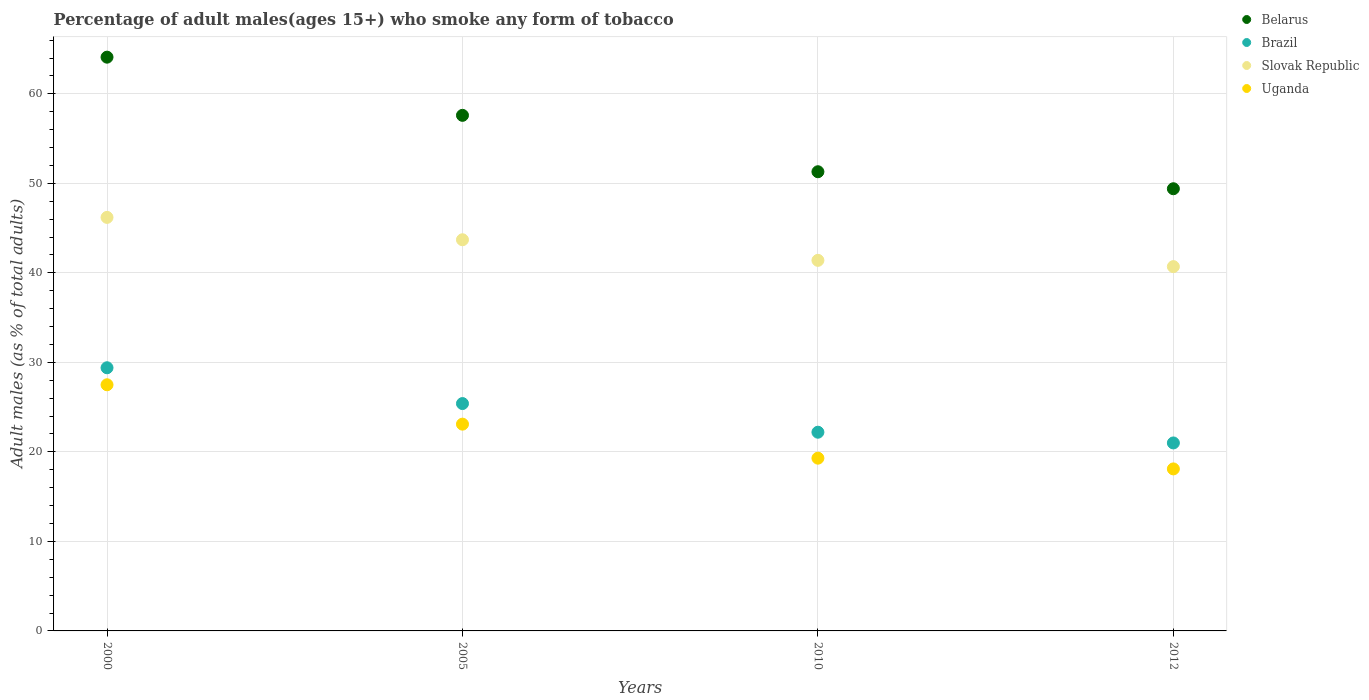How many different coloured dotlines are there?
Make the answer very short. 4. Is the number of dotlines equal to the number of legend labels?
Your answer should be compact. Yes. What is the percentage of adult males who smoke in Belarus in 2005?
Provide a short and direct response. 57.6. Across all years, what is the maximum percentage of adult males who smoke in Brazil?
Offer a very short reply. 29.4. Across all years, what is the minimum percentage of adult males who smoke in Slovak Republic?
Your response must be concise. 40.7. In which year was the percentage of adult males who smoke in Uganda maximum?
Provide a short and direct response. 2000. In which year was the percentage of adult males who smoke in Belarus minimum?
Provide a succinct answer. 2012. What is the total percentage of adult males who smoke in Belarus in the graph?
Offer a very short reply. 222.4. What is the difference between the percentage of adult males who smoke in Belarus in 2000 and that in 2005?
Provide a short and direct response. 6.5. What is the difference between the percentage of adult males who smoke in Belarus in 2005 and the percentage of adult males who smoke in Uganda in 2000?
Make the answer very short. 30.1. What is the average percentage of adult males who smoke in Belarus per year?
Your response must be concise. 55.6. In the year 2012, what is the difference between the percentage of adult males who smoke in Brazil and percentage of adult males who smoke in Slovak Republic?
Make the answer very short. -19.7. What is the ratio of the percentage of adult males who smoke in Slovak Republic in 2010 to that in 2012?
Your response must be concise. 1.02. Is the percentage of adult males who smoke in Slovak Republic in 2005 less than that in 2012?
Make the answer very short. No. What is the difference between the highest and the lowest percentage of adult males who smoke in Brazil?
Offer a very short reply. 8.4. Is the sum of the percentage of adult males who smoke in Uganda in 2005 and 2010 greater than the maximum percentage of adult males who smoke in Belarus across all years?
Your answer should be compact. No. Is the percentage of adult males who smoke in Brazil strictly greater than the percentage of adult males who smoke in Slovak Republic over the years?
Provide a short and direct response. No. How many years are there in the graph?
Make the answer very short. 4. Where does the legend appear in the graph?
Ensure brevity in your answer.  Top right. How are the legend labels stacked?
Offer a terse response. Vertical. What is the title of the graph?
Your answer should be compact. Percentage of adult males(ages 15+) who smoke any form of tobacco. What is the label or title of the Y-axis?
Your answer should be very brief. Adult males (as % of total adults). What is the Adult males (as % of total adults) in Belarus in 2000?
Make the answer very short. 64.1. What is the Adult males (as % of total adults) of Brazil in 2000?
Your response must be concise. 29.4. What is the Adult males (as % of total adults) of Slovak Republic in 2000?
Provide a short and direct response. 46.2. What is the Adult males (as % of total adults) of Uganda in 2000?
Ensure brevity in your answer.  27.5. What is the Adult males (as % of total adults) in Belarus in 2005?
Your answer should be very brief. 57.6. What is the Adult males (as % of total adults) of Brazil in 2005?
Ensure brevity in your answer.  25.4. What is the Adult males (as % of total adults) in Slovak Republic in 2005?
Your response must be concise. 43.7. What is the Adult males (as % of total adults) of Uganda in 2005?
Provide a succinct answer. 23.1. What is the Adult males (as % of total adults) of Belarus in 2010?
Your response must be concise. 51.3. What is the Adult males (as % of total adults) of Brazil in 2010?
Offer a terse response. 22.2. What is the Adult males (as % of total adults) in Slovak Republic in 2010?
Offer a terse response. 41.4. What is the Adult males (as % of total adults) of Uganda in 2010?
Provide a succinct answer. 19.3. What is the Adult males (as % of total adults) in Belarus in 2012?
Your response must be concise. 49.4. What is the Adult males (as % of total adults) in Brazil in 2012?
Offer a very short reply. 21. What is the Adult males (as % of total adults) in Slovak Republic in 2012?
Keep it short and to the point. 40.7. Across all years, what is the maximum Adult males (as % of total adults) in Belarus?
Ensure brevity in your answer.  64.1. Across all years, what is the maximum Adult males (as % of total adults) in Brazil?
Offer a terse response. 29.4. Across all years, what is the maximum Adult males (as % of total adults) of Slovak Republic?
Offer a very short reply. 46.2. Across all years, what is the minimum Adult males (as % of total adults) in Belarus?
Your response must be concise. 49.4. Across all years, what is the minimum Adult males (as % of total adults) of Brazil?
Ensure brevity in your answer.  21. Across all years, what is the minimum Adult males (as % of total adults) in Slovak Republic?
Offer a very short reply. 40.7. What is the total Adult males (as % of total adults) in Belarus in the graph?
Offer a terse response. 222.4. What is the total Adult males (as % of total adults) in Slovak Republic in the graph?
Keep it short and to the point. 172. What is the total Adult males (as % of total adults) in Uganda in the graph?
Keep it short and to the point. 88. What is the difference between the Adult males (as % of total adults) of Belarus in 2000 and that in 2010?
Your answer should be compact. 12.8. What is the difference between the Adult males (as % of total adults) of Brazil in 2000 and that in 2010?
Ensure brevity in your answer.  7.2. What is the difference between the Adult males (as % of total adults) of Belarus in 2000 and that in 2012?
Provide a succinct answer. 14.7. What is the difference between the Adult males (as % of total adults) of Brazil in 2000 and that in 2012?
Ensure brevity in your answer.  8.4. What is the difference between the Adult males (as % of total adults) in Belarus in 2005 and that in 2012?
Offer a very short reply. 8.2. What is the difference between the Adult males (as % of total adults) in Brazil in 2005 and that in 2012?
Provide a succinct answer. 4.4. What is the difference between the Adult males (as % of total adults) in Belarus in 2010 and that in 2012?
Give a very brief answer. 1.9. What is the difference between the Adult males (as % of total adults) of Slovak Republic in 2010 and that in 2012?
Keep it short and to the point. 0.7. What is the difference between the Adult males (as % of total adults) of Belarus in 2000 and the Adult males (as % of total adults) of Brazil in 2005?
Keep it short and to the point. 38.7. What is the difference between the Adult males (as % of total adults) in Belarus in 2000 and the Adult males (as % of total adults) in Slovak Republic in 2005?
Ensure brevity in your answer.  20.4. What is the difference between the Adult males (as % of total adults) in Belarus in 2000 and the Adult males (as % of total adults) in Uganda in 2005?
Ensure brevity in your answer.  41. What is the difference between the Adult males (as % of total adults) in Brazil in 2000 and the Adult males (as % of total adults) in Slovak Republic in 2005?
Ensure brevity in your answer.  -14.3. What is the difference between the Adult males (as % of total adults) in Slovak Republic in 2000 and the Adult males (as % of total adults) in Uganda in 2005?
Offer a very short reply. 23.1. What is the difference between the Adult males (as % of total adults) of Belarus in 2000 and the Adult males (as % of total adults) of Brazil in 2010?
Make the answer very short. 41.9. What is the difference between the Adult males (as % of total adults) in Belarus in 2000 and the Adult males (as % of total adults) in Slovak Republic in 2010?
Your response must be concise. 22.7. What is the difference between the Adult males (as % of total adults) in Belarus in 2000 and the Adult males (as % of total adults) in Uganda in 2010?
Your answer should be very brief. 44.8. What is the difference between the Adult males (as % of total adults) in Brazil in 2000 and the Adult males (as % of total adults) in Uganda in 2010?
Offer a terse response. 10.1. What is the difference between the Adult males (as % of total adults) of Slovak Republic in 2000 and the Adult males (as % of total adults) of Uganda in 2010?
Offer a very short reply. 26.9. What is the difference between the Adult males (as % of total adults) in Belarus in 2000 and the Adult males (as % of total adults) in Brazil in 2012?
Offer a very short reply. 43.1. What is the difference between the Adult males (as % of total adults) in Belarus in 2000 and the Adult males (as % of total adults) in Slovak Republic in 2012?
Your answer should be compact. 23.4. What is the difference between the Adult males (as % of total adults) of Belarus in 2000 and the Adult males (as % of total adults) of Uganda in 2012?
Your answer should be very brief. 46. What is the difference between the Adult males (as % of total adults) in Slovak Republic in 2000 and the Adult males (as % of total adults) in Uganda in 2012?
Give a very brief answer. 28.1. What is the difference between the Adult males (as % of total adults) in Belarus in 2005 and the Adult males (as % of total adults) in Brazil in 2010?
Make the answer very short. 35.4. What is the difference between the Adult males (as % of total adults) in Belarus in 2005 and the Adult males (as % of total adults) in Uganda in 2010?
Offer a terse response. 38.3. What is the difference between the Adult males (as % of total adults) of Slovak Republic in 2005 and the Adult males (as % of total adults) of Uganda in 2010?
Provide a succinct answer. 24.4. What is the difference between the Adult males (as % of total adults) of Belarus in 2005 and the Adult males (as % of total adults) of Brazil in 2012?
Provide a succinct answer. 36.6. What is the difference between the Adult males (as % of total adults) in Belarus in 2005 and the Adult males (as % of total adults) in Slovak Republic in 2012?
Provide a short and direct response. 16.9. What is the difference between the Adult males (as % of total adults) of Belarus in 2005 and the Adult males (as % of total adults) of Uganda in 2012?
Ensure brevity in your answer.  39.5. What is the difference between the Adult males (as % of total adults) in Brazil in 2005 and the Adult males (as % of total adults) in Slovak Republic in 2012?
Make the answer very short. -15.3. What is the difference between the Adult males (as % of total adults) of Slovak Republic in 2005 and the Adult males (as % of total adults) of Uganda in 2012?
Make the answer very short. 25.6. What is the difference between the Adult males (as % of total adults) of Belarus in 2010 and the Adult males (as % of total adults) of Brazil in 2012?
Provide a succinct answer. 30.3. What is the difference between the Adult males (as % of total adults) of Belarus in 2010 and the Adult males (as % of total adults) of Uganda in 2012?
Offer a terse response. 33.2. What is the difference between the Adult males (as % of total adults) of Brazil in 2010 and the Adult males (as % of total adults) of Slovak Republic in 2012?
Your response must be concise. -18.5. What is the difference between the Adult males (as % of total adults) of Slovak Republic in 2010 and the Adult males (as % of total adults) of Uganda in 2012?
Give a very brief answer. 23.3. What is the average Adult males (as % of total adults) in Belarus per year?
Your answer should be compact. 55.6. What is the average Adult males (as % of total adults) in Brazil per year?
Your response must be concise. 24.5. What is the average Adult males (as % of total adults) of Slovak Republic per year?
Give a very brief answer. 43. What is the average Adult males (as % of total adults) of Uganda per year?
Make the answer very short. 22. In the year 2000, what is the difference between the Adult males (as % of total adults) of Belarus and Adult males (as % of total adults) of Brazil?
Offer a terse response. 34.7. In the year 2000, what is the difference between the Adult males (as % of total adults) of Belarus and Adult males (as % of total adults) of Uganda?
Ensure brevity in your answer.  36.6. In the year 2000, what is the difference between the Adult males (as % of total adults) of Brazil and Adult males (as % of total adults) of Slovak Republic?
Your answer should be compact. -16.8. In the year 2000, what is the difference between the Adult males (as % of total adults) of Slovak Republic and Adult males (as % of total adults) of Uganda?
Your answer should be very brief. 18.7. In the year 2005, what is the difference between the Adult males (as % of total adults) in Belarus and Adult males (as % of total adults) in Brazil?
Your answer should be compact. 32.2. In the year 2005, what is the difference between the Adult males (as % of total adults) of Belarus and Adult males (as % of total adults) of Uganda?
Provide a short and direct response. 34.5. In the year 2005, what is the difference between the Adult males (as % of total adults) of Brazil and Adult males (as % of total adults) of Slovak Republic?
Ensure brevity in your answer.  -18.3. In the year 2005, what is the difference between the Adult males (as % of total adults) in Slovak Republic and Adult males (as % of total adults) in Uganda?
Offer a terse response. 20.6. In the year 2010, what is the difference between the Adult males (as % of total adults) of Belarus and Adult males (as % of total adults) of Brazil?
Keep it short and to the point. 29.1. In the year 2010, what is the difference between the Adult males (as % of total adults) of Belarus and Adult males (as % of total adults) of Uganda?
Provide a short and direct response. 32. In the year 2010, what is the difference between the Adult males (as % of total adults) in Brazil and Adult males (as % of total adults) in Slovak Republic?
Give a very brief answer. -19.2. In the year 2010, what is the difference between the Adult males (as % of total adults) of Brazil and Adult males (as % of total adults) of Uganda?
Provide a short and direct response. 2.9. In the year 2010, what is the difference between the Adult males (as % of total adults) of Slovak Republic and Adult males (as % of total adults) of Uganda?
Your answer should be very brief. 22.1. In the year 2012, what is the difference between the Adult males (as % of total adults) of Belarus and Adult males (as % of total adults) of Brazil?
Offer a very short reply. 28.4. In the year 2012, what is the difference between the Adult males (as % of total adults) of Belarus and Adult males (as % of total adults) of Slovak Republic?
Ensure brevity in your answer.  8.7. In the year 2012, what is the difference between the Adult males (as % of total adults) in Belarus and Adult males (as % of total adults) in Uganda?
Your answer should be very brief. 31.3. In the year 2012, what is the difference between the Adult males (as % of total adults) of Brazil and Adult males (as % of total adults) of Slovak Republic?
Make the answer very short. -19.7. In the year 2012, what is the difference between the Adult males (as % of total adults) in Brazil and Adult males (as % of total adults) in Uganda?
Your response must be concise. 2.9. In the year 2012, what is the difference between the Adult males (as % of total adults) in Slovak Republic and Adult males (as % of total adults) in Uganda?
Offer a very short reply. 22.6. What is the ratio of the Adult males (as % of total adults) in Belarus in 2000 to that in 2005?
Your response must be concise. 1.11. What is the ratio of the Adult males (as % of total adults) of Brazil in 2000 to that in 2005?
Ensure brevity in your answer.  1.16. What is the ratio of the Adult males (as % of total adults) of Slovak Republic in 2000 to that in 2005?
Offer a terse response. 1.06. What is the ratio of the Adult males (as % of total adults) of Uganda in 2000 to that in 2005?
Offer a terse response. 1.19. What is the ratio of the Adult males (as % of total adults) of Belarus in 2000 to that in 2010?
Provide a succinct answer. 1.25. What is the ratio of the Adult males (as % of total adults) of Brazil in 2000 to that in 2010?
Offer a terse response. 1.32. What is the ratio of the Adult males (as % of total adults) of Slovak Republic in 2000 to that in 2010?
Keep it short and to the point. 1.12. What is the ratio of the Adult males (as % of total adults) of Uganda in 2000 to that in 2010?
Offer a terse response. 1.42. What is the ratio of the Adult males (as % of total adults) in Belarus in 2000 to that in 2012?
Provide a succinct answer. 1.3. What is the ratio of the Adult males (as % of total adults) of Brazil in 2000 to that in 2012?
Offer a terse response. 1.4. What is the ratio of the Adult males (as % of total adults) of Slovak Republic in 2000 to that in 2012?
Your answer should be very brief. 1.14. What is the ratio of the Adult males (as % of total adults) of Uganda in 2000 to that in 2012?
Offer a terse response. 1.52. What is the ratio of the Adult males (as % of total adults) of Belarus in 2005 to that in 2010?
Your answer should be very brief. 1.12. What is the ratio of the Adult males (as % of total adults) of Brazil in 2005 to that in 2010?
Give a very brief answer. 1.14. What is the ratio of the Adult males (as % of total adults) in Slovak Republic in 2005 to that in 2010?
Your response must be concise. 1.06. What is the ratio of the Adult males (as % of total adults) in Uganda in 2005 to that in 2010?
Provide a short and direct response. 1.2. What is the ratio of the Adult males (as % of total adults) of Belarus in 2005 to that in 2012?
Your answer should be compact. 1.17. What is the ratio of the Adult males (as % of total adults) of Brazil in 2005 to that in 2012?
Provide a short and direct response. 1.21. What is the ratio of the Adult males (as % of total adults) of Slovak Republic in 2005 to that in 2012?
Your answer should be very brief. 1.07. What is the ratio of the Adult males (as % of total adults) of Uganda in 2005 to that in 2012?
Provide a short and direct response. 1.28. What is the ratio of the Adult males (as % of total adults) of Belarus in 2010 to that in 2012?
Provide a short and direct response. 1.04. What is the ratio of the Adult males (as % of total adults) in Brazil in 2010 to that in 2012?
Your answer should be compact. 1.06. What is the ratio of the Adult males (as % of total adults) of Slovak Republic in 2010 to that in 2012?
Offer a terse response. 1.02. What is the ratio of the Adult males (as % of total adults) in Uganda in 2010 to that in 2012?
Your answer should be very brief. 1.07. What is the difference between the highest and the second highest Adult males (as % of total adults) in Brazil?
Your response must be concise. 4. What is the difference between the highest and the second highest Adult males (as % of total adults) in Uganda?
Provide a short and direct response. 4.4. What is the difference between the highest and the lowest Adult males (as % of total adults) of Brazil?
Your answer should be very brief. 8.4. What is the difference between the highest and the lowest Adult males (as % of total adults) of Slovak Republic?
Keep it short and to the point. 5.5. What is the difference between the highest and the lowest Adult males (as % of total adults) in Uganda?
Provide a short and direct response. 9.4. 